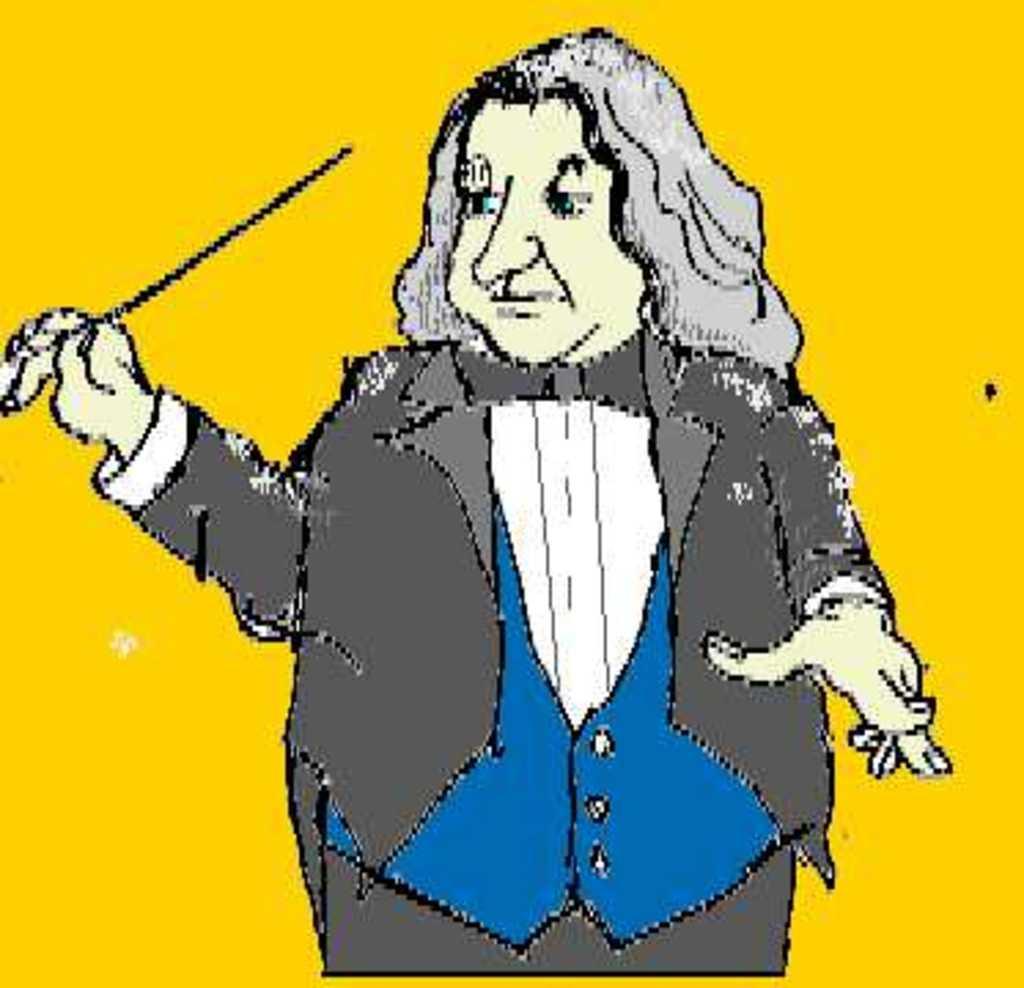Describe this image in one or two sentences. This is an edited and cartoon cartoon image, where the person is standing in the center holding a stick. 